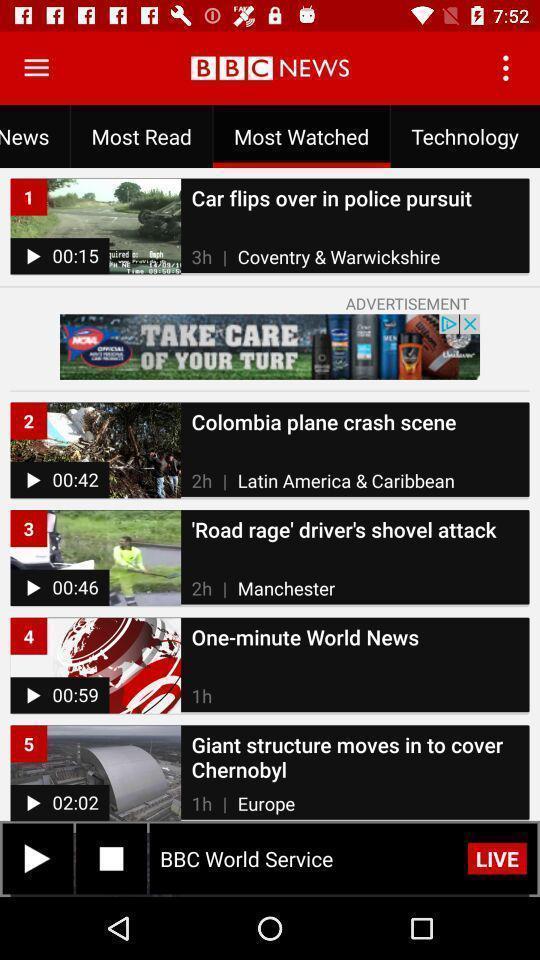What details can you identify in this image? Screen displaying multiple videos in a news channel. 